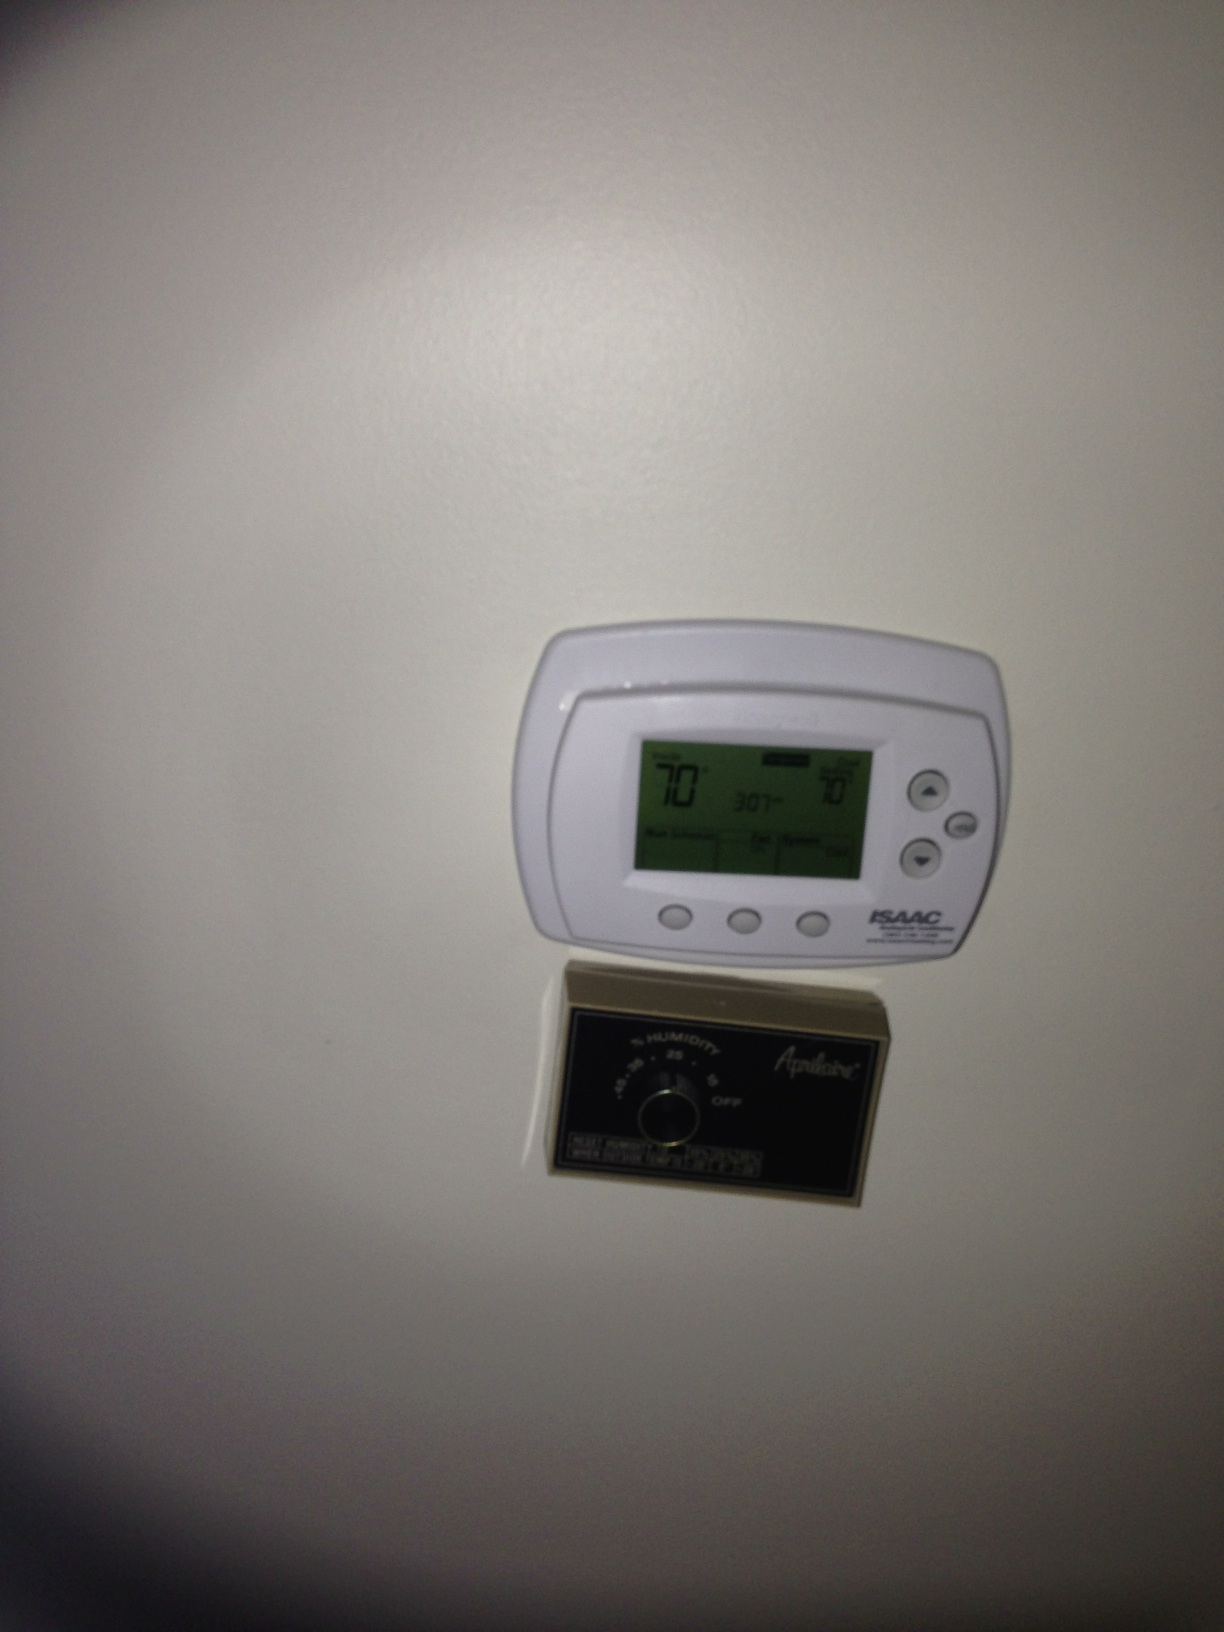Imagine this thermometer could talk. What would it say about its role in the home? Hello! I'm your trusty home thermometer, diligently working to keep the temperature and humidity just right for you. I make sure you're cozy when it's cold and cool when it's hot, all while keeping an eye on the air's moisture to prevent that pesky dry air or muggy feeling. Let's keep things comfortable and efficient together! If the thermometer panel had a hidden feature, what would be the coolest hidden feature you can imagine? Imagine if the thermometer panel had a hidden time travel button! Pressing it could allow you to experience different historical climates firsthand — feel the icy chills of the Ice Age or the tropical warmth of the age of dinosaurs. It would be an exciting and educational journey through Earth's climatic history! In what other scenarios might this humidity control panel be especially useful? This humidity control panel would be especially useful in homes with musical instruments like pianos or guitars, which require stable humidity to stay in tune. It's also vital in areas with wooden furniture or flooring to prevent warping and cracking. Additionally, homes with residents who have respiratory issues might benefit from fine-tuning the air's moisture for health reasons. Could you write a short scenario where adjusting the temperature and humidity dramatically changes someone's day? Sure! It's a sweltering summer afternoon, and Jamie's home feels like a sauna. The thermometer squawks, reminding them to lower the temperature and dehumidify the air. With a couple of button presses, cool air floods the house, and the sticky humidity fades away. Jamie can finally relax with a refreshing drink in complete comfort, escaping the oppressive heat outside. The day transforms from unbearable to blissful, all thanks to the handy controls. 